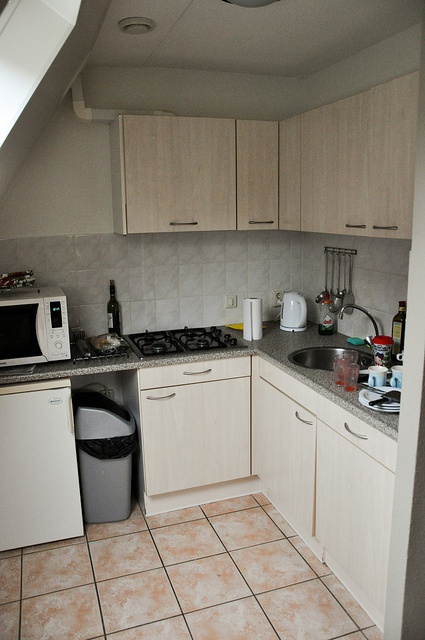Describe the objects in this image and their specific colors. I can see oven in black, lightgray, and darkgray tones, refrigerator in black, darkgray, and lightgray tones, microwave in black, darkgray, and gray tones, sink in black, gray, and darkgray tones, and bottle in black, gray, and olive tones in this image. 